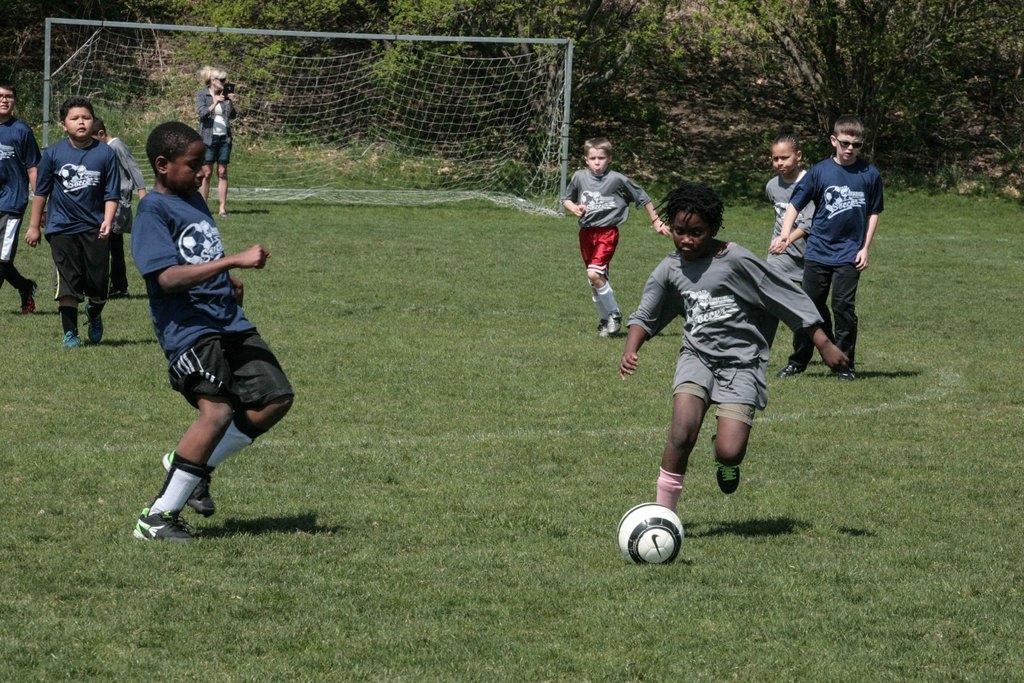Could you give a brief overview of what you see in this image? In this image there are group of people who are running towards ball and they are playing a football and on the left side there are some people who are walking and in the bottom there is some grass, and on the top there are some trees and on the left side there is a net. 